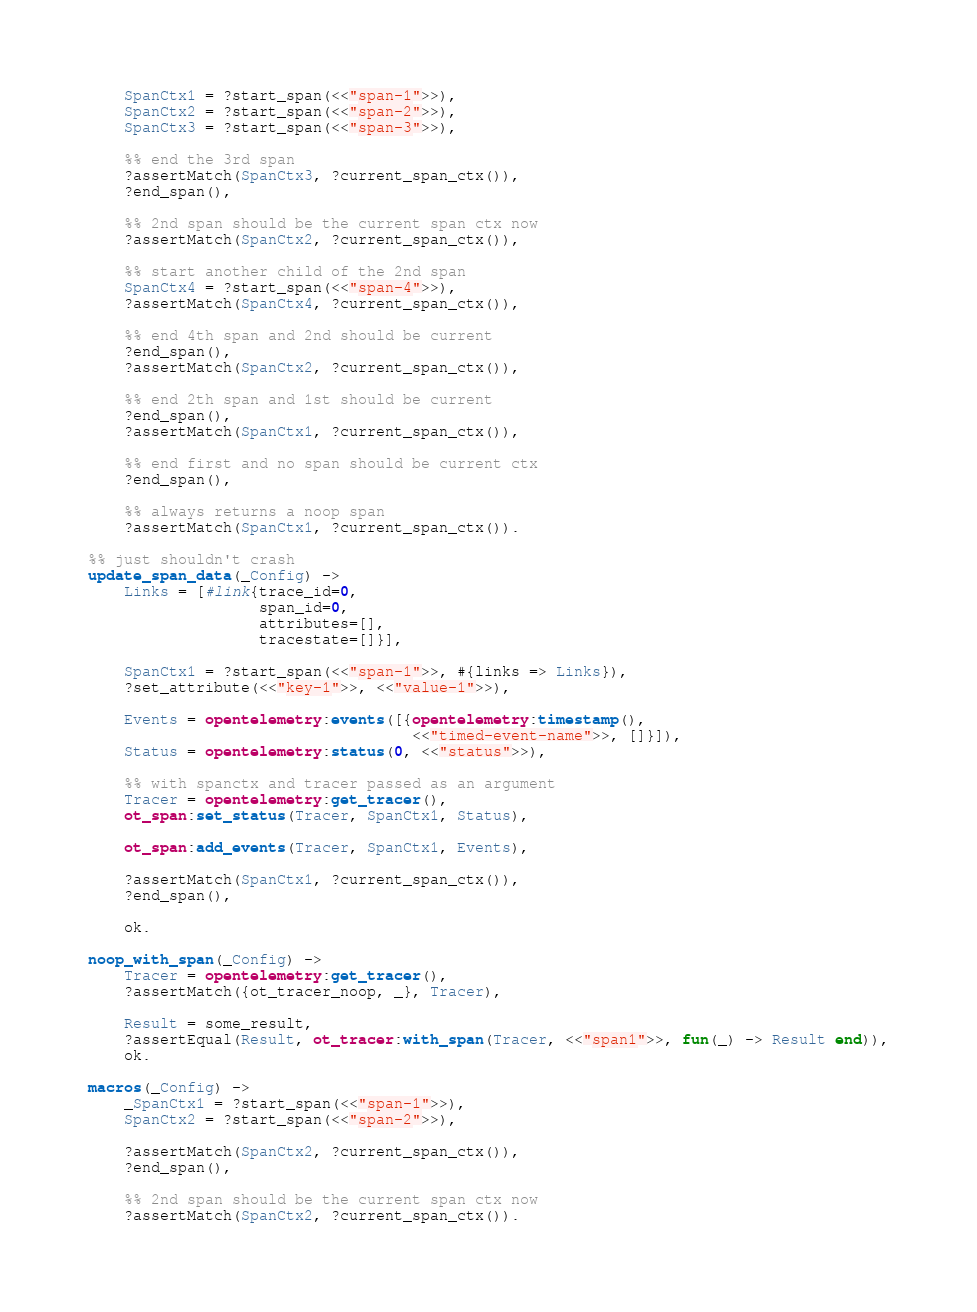Convert code to text. <code><loc_0><loc_0><loc_500><loc_500><_Erlang_>    SpanCtx1 = ?start_span(<<"span-1">>),
    SpanCtx2 = ?start_span(<<"span-2">>),
    SpanCtx3 = ?start_span(<<"span-3">>),

    %% end the 3rd span
    ?assertMatch(SpanCtx3, ?current_span_ctx()),
    ?end_span(),

    %% 2nd span should be the current span ctx now
    ?assertMatch(SpanCtx2, ?current_span_ctx()),

    %% start another child of the 2nd span
    SpanCtx4 = ?start_span(<<"span-4">>),
    ?assertMatch(SpanCtx4, ?current_span_ctx()),

    %% end 4th span and 2nd should be current
    ?end_span(),
    ?assertMatch(SpanCtx2, ?current_span_ctx()),

    %% end 2th span and 1st should be current
    ?end_span(),
    ?assertMatch(SpanCtx1, ?current_span_ctx()),

    %% end first and no span should be current ctx
    ?end_span(),

    %% always returns a noop span
    ?assertMatch(SpanCtx1, ?current_span_ctx()).

%% just shouldn't crash
update_span_data(_Config) ->
    Links = [#link{trace_id=0,
                   span_id=0,
                   attributes=[],
                   tracestate=[]}],

    SpanCtx1 = ?start_span(<<"span-1">>, #{links => Links}),
    ?set_attribute(<<"key-1">>, <<"value-1">>),

    Events = opentelemetry:events([{opentelemetry:timestamp(),
                                    <<"timed-event-name">>, []}]),
    Status = opentelemetry:status(0, <<"status">>),

    %% with spanctx and tracer passed as an argument
    Tracer = opentelemetry:get_tracer(),
    ot_span:set_status(Tracer, SpanCtx1, Status),

    ot_span:add_events(Tracer, SpanCtx1, Events),

    ?assertMatch(SpanCtx1, ?current_span_ctx()),
    ?end_span(),

    ok.

noop_with_span(_Config) ->
    Tracer = opentelemetry:get_tracer(),
    ?assertMatch({ot_tracer_noop, _}, Tracer),

    Result = some_result,
    ?assertEqual(Result, ot_tracer:with_span(Tracer, <<"span1">>, fun(_) -> Result end)),
    ok.

macros(_Config) ->
    _SpanCtx1 = ?start_span(<<"span-1">>),
    SpanCtx2 = ?start_span(<<"span-2">>),

    ?assertMatch(SpanCtx2, ?current_span_ctx()),
    ?end_span(),

    %% 2nd span should be the current span ctx now
    ?assertMatch(SpanCtx2, ?current_span_ctx()).
</code> 